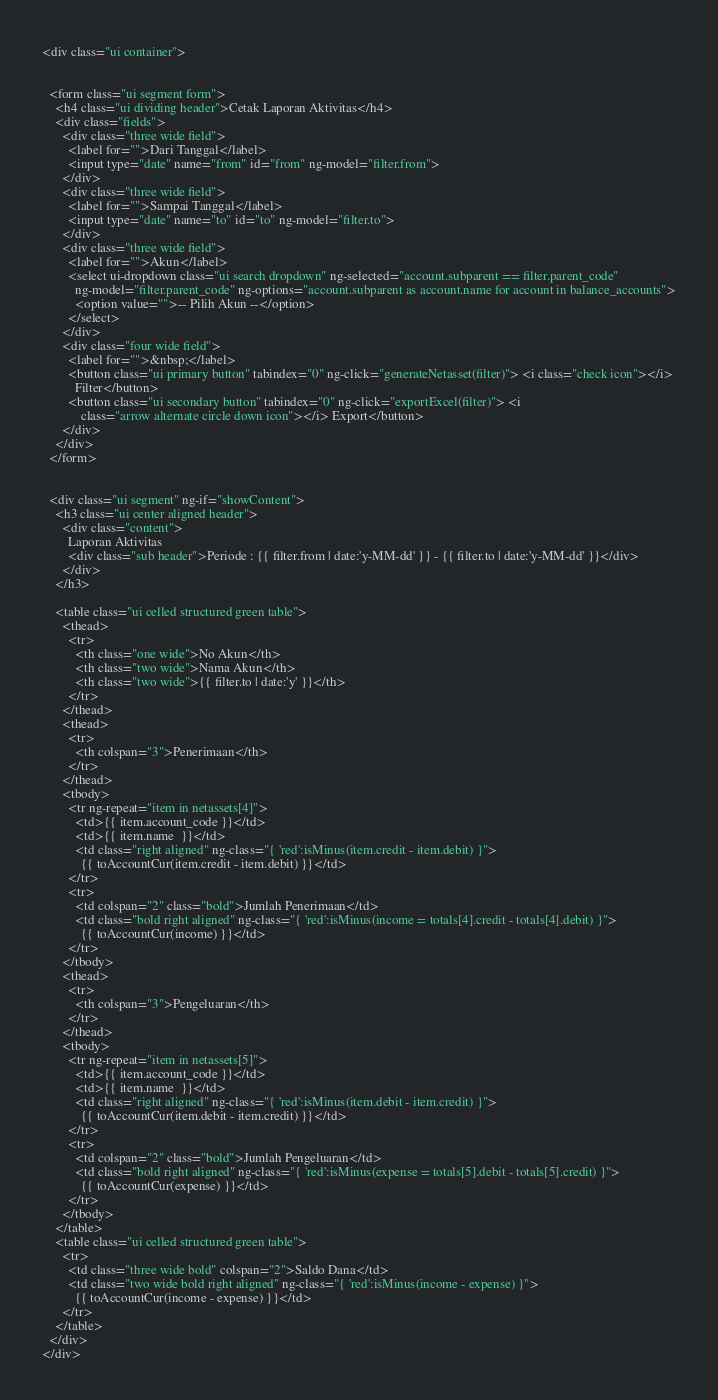<code> <loc_0><loc_0><loc_500><loc_500><_HTML_><div class="ui container">


  <form class="ui segment form">
    <h4 class="ui dividing header">Cetak Laporan Aktivitas</h4>
    <div class="fields">
      <div class="three wide field">
        <label for="">Dari Tanggal</label>
        <input type="date" name="from" id="from" ng-model="filter.from">
      </div>
      <div class="three wide field">
        <label for="">Sampai Tanggal</label>
        <input type="date" name="to" id="to" ng-model="filter.to">
      </div>
      <div class="three wide field">
        <label for="">Akun</label>
        <select ui-dropdown class="ui search dropdown" ng-selected="account.subparent == filter.parent_code"
          ng-model="filter.parent_code" ng-options="account.subparent as account.name for account in balance_accounts">
          <option value="">-- Pilih Akun --</option>
        </select>
      </div>
      <div class="four wide field">
        <label for="">&nbsp;</label>
        <button class="ui primary button" tabindex="0" ng-click="generateNetasset(filter)"> <i class="check icon"></i>
          Filter</button>
        <button class="ui secondary button" tabindex="0" ng-click="exportExcel(filter)"> <i
            class="arrow alternate circle down icon"></i> Export</button>
      </div>
    </div>
  </form>


  <div class="ui segment" ng-if="showContent">
    <h3 class="ui center aligned header">
      <div class="content">
        Laporan Aktivitas
        <div class="sub header">Periode : {{ filter.from | date:'y-MM-dd' }} - {{ filter.to | date:'y-MM-dd' }}</div>
      </div>
    </h3>

    <table class="ui celled structured green table">
      <thead>
        <tr>
          <th class="one wide">No Akun</th>
          <th class="two wide">Nama Akun</th>
          <th class="two wide">{{ filter.to | date:'y' }}</th>
        </tr>
      </thead>
      <thead>
        <tr>
          <th colspan="3">Penerimaan</th>
        </tr>
      </thead>
      <tbody>
        <tr ng-repeat="item in netassets[4]">
          <td>{{ item.account_code }}</td>
          <td>{{ item.name  }}</td>
          <td class="right aligned" ng-class="{ 'red':isMinus(item.credit - item.debit) }">
            {{ toAccountCur(item.credit - item.debit) }}</td>
        </tr>
        <tr>
          <td colspan="2" class="bold">Jumlah Penerimaan</td>
          <td class="bold right aligned" ng-class="{ 'red':isMinus(income = totals[4].credit - totals[4].debit) }">
            {{ toAccountCur(income) }}</td>
        </tr>
      </tbody>
      <thead>
        <tr>
          <th colspan="3">Pengeluaran</th>
        </tr>
      </thead>
      <tbody>
        <tr ng-repeat="item in netassets[5]">
          <td>{{ item.account_code }}</td>
          <td>{{ item.name  }}</td>
          <td class="right aligned" ng-class="{ 'red':isMinus(item.debit - item.credit) }">
            {{ toAccountCur(item.debit - item.credit) }}</td>
        </tr>
        <tr>
          <td colspan="2" class="bold">Jumlah Pengeluaran</td>
          <td class="bold right aligned" ng-class="{ 'red':isMinus(expense = totals[5].debit - totals[5].credit) }">
            {{ toAccountCur(expense) }}</td>
        </tr>
      </tbody>
    </table>
    <table class="ui celled structured green table">
      <tr>
        <td class="three wide bold" colspan="2">Saldo Dana</td>
        <td class="two wide bold right aligned" ng-class="{ 'red':isMinus(income - expense) }">
          {{ toAccountCur(income - expense) }}</td>
      </tr>
    </table>
  </div>
</div></code> 